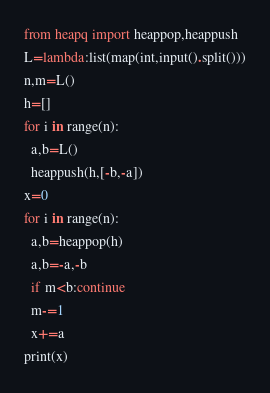<code> <loc_0><loc_0><loc_500><loc_500><_Python_>from heapq import heappop,heappush
L=lambda:list(map(int,input().split()))
n,m=L()
h=[]
for i in range(n):
  a,b=L()
  heappush(h,[-b,-a])
x=0
for i in range(n):
  a,b=heappop(h)
  a,b=-a,-b
  if m<b:continue
  m-=1
  x+=a
print(x)</code> 